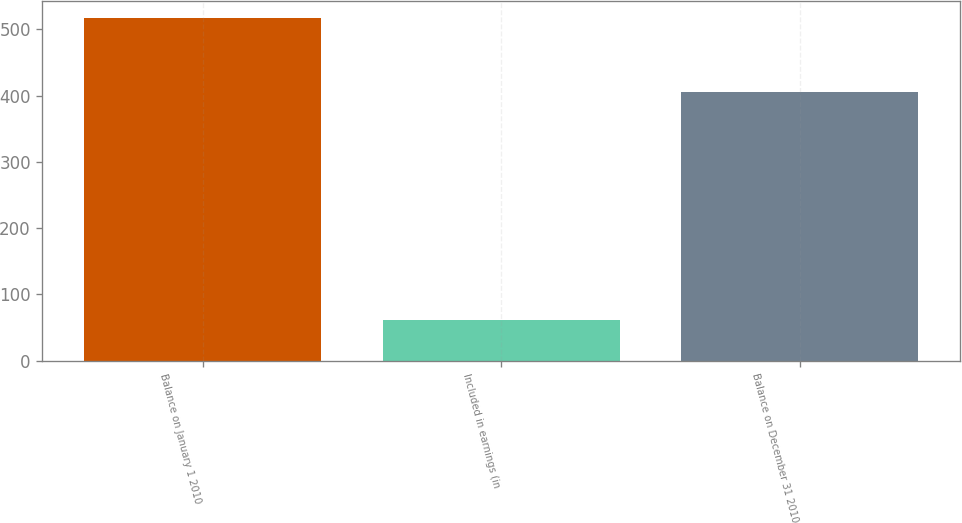<chart> <loc_0><loc_0><loc_500><loc_500><bar_chart><fcel>Balance on January 1 2010<fcel>Included in earnings (in<fcel>Balance on December 31 2010<nl><fcel>517<fcel>61<fcel>405<nl></chart> 